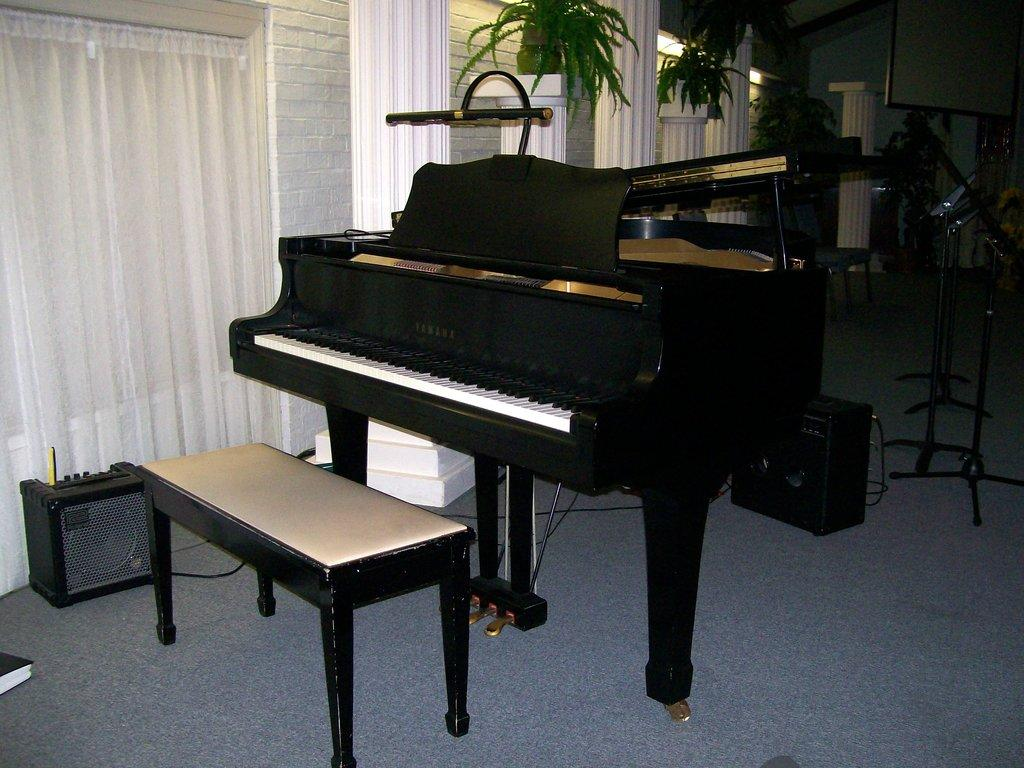What musical instruments can be seen in the room? There are instruments in the room, including a microphone and a keyboard. What piece of furniture is present in the room? There is a table in the room. What type of decorative element is present in the room? There are plants in the room. How would you describe the lighting in the room? The background of the image appears to be a little dark. What type of jeans is the person wearing in the image? There is no person visible in the image, so it is not possible to determine what type of jeans they might be wearing. 